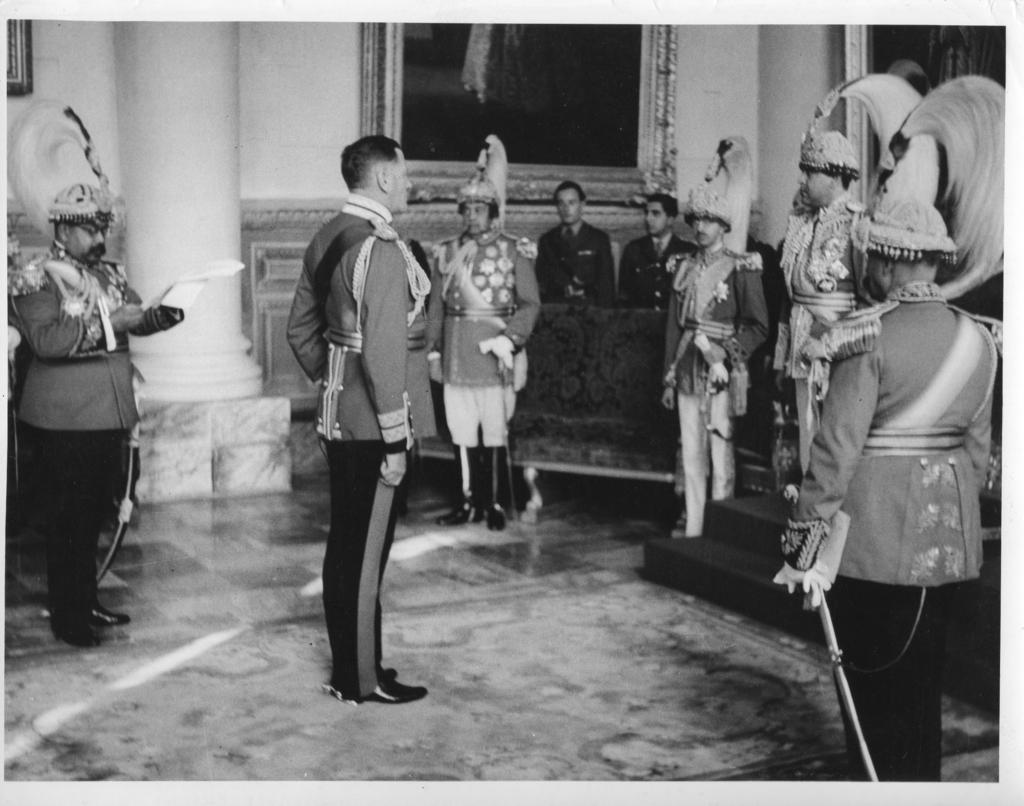How many people are present in the image? There are many people in the image. What is at the bottom of the image? There is a floor at the bottom of the image. What are the people wearing in the image? The people are wearing costumes. What can be seen on the wall in the front of the image? There are frames fixed on the wall in the front of the image. What architectural feature is present in the image? There is a pillar in the image. Can you tell me how many tickets are needed to enter the hospital in the image? There is no hospital or tickets present in the image. What type of stem is growing from the pillar in the image? There is no stem growing from the pillar in the image. 